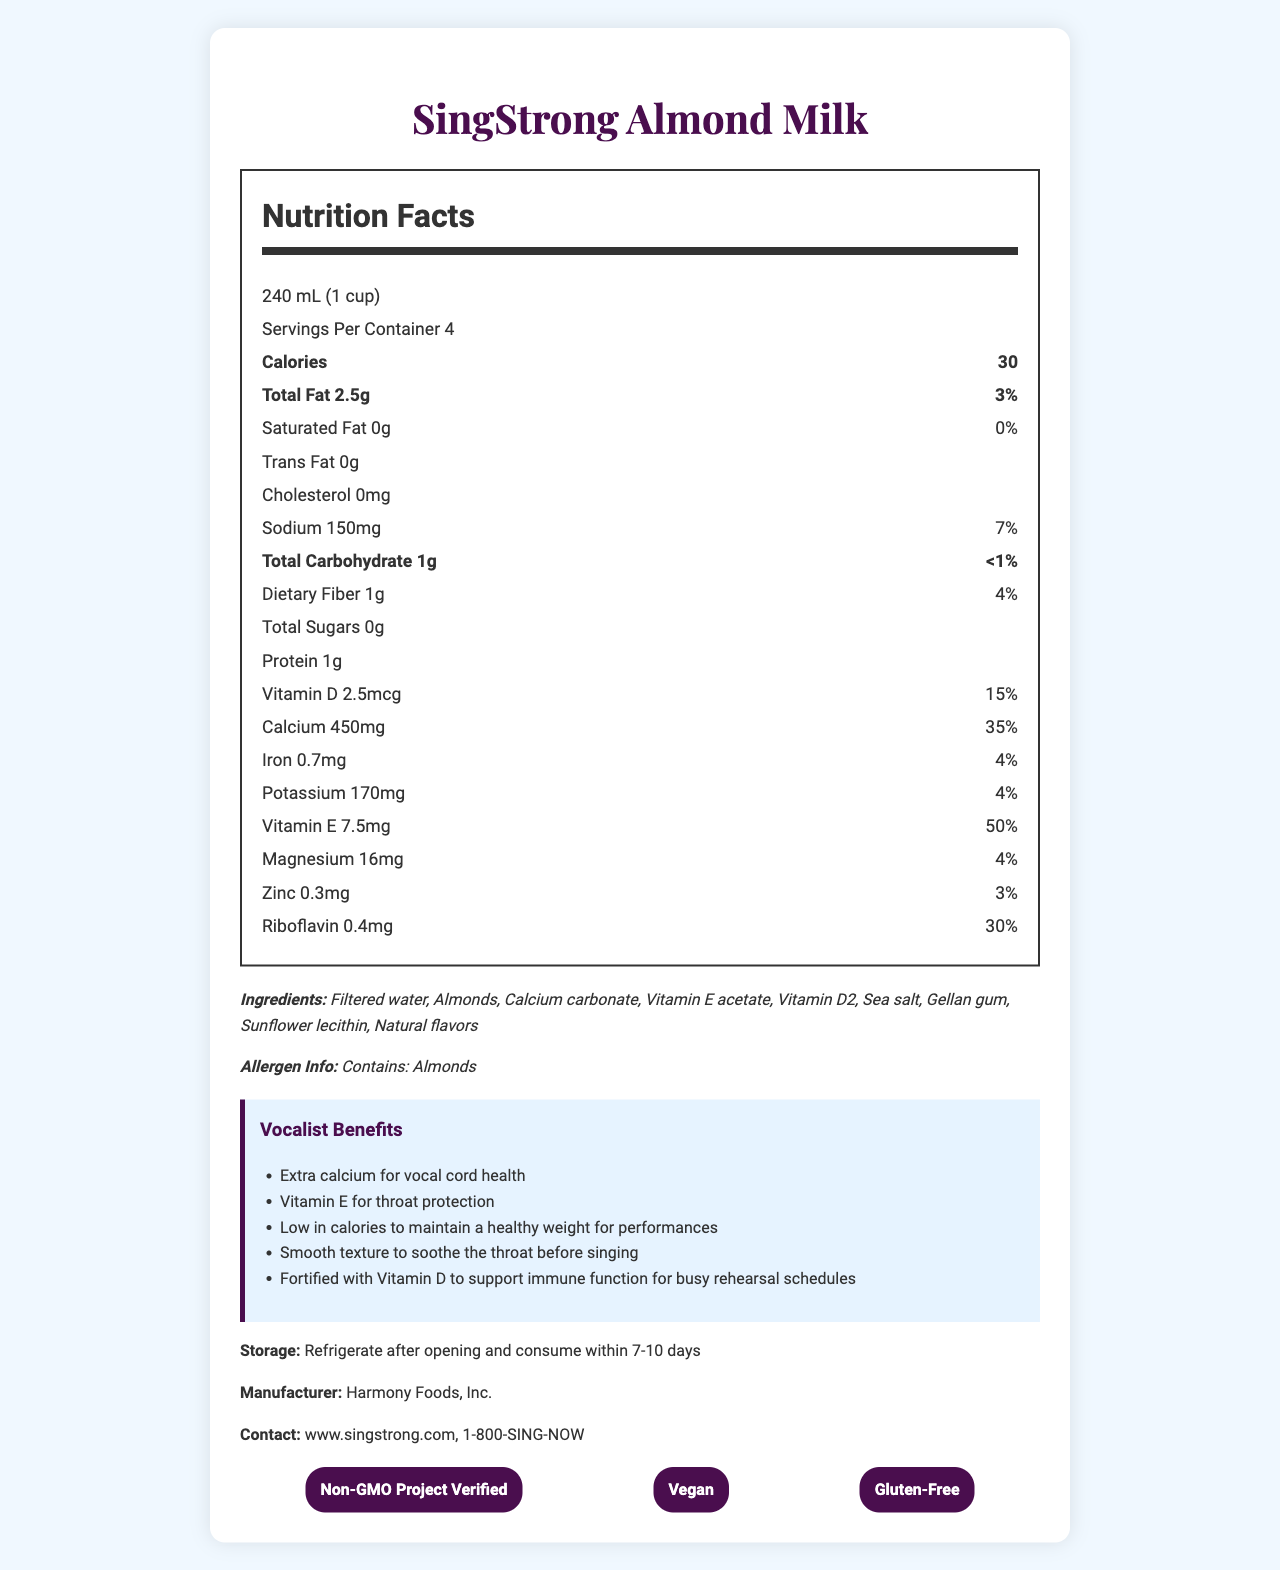what is the serving size of SingStrong Almond Milk? The serving size is clearly specified at the beginning of the nutrition label section.
Answer: 240 mL (1 cup) how many calories are there in one serving? The calories per serving are listed next to the serving size information.
Answer: 30 what is the amount of sodium in one serving? The sodium amount is listed under the nutrition facts with its daily value percentage.
Answer: 150mg how much calcium does SingStrong Almond Milk provide per serving? The calcium amount and its daily value are prominently mentioned in the nutrition facts.
Answer: 450mg how much protein is in a serving? The protein content is listed under the nutrition facts.
Answer: 1g What ingredients are used in SingStrong Almond Milk? The ingredients are listed under the ingredients section of the document.
Answer: Filtered water, Almonds, Calcium carbonate, Vitamin E acetate, Vitamin D2, Sea salt, Gellan gum, Sunflower lecithin, Natural flavors What certifications does SingStrong Almond Milk have? A. Organic B. Non-GMO Project Verified C. Kosher D. Gluten-Free The certifications listed are Non-GMO Project Verified, Vegan, Gluten-Free.
Answer: B, D Which vitamin is present in the highest daily value percentage in SingStrong Almond Milk? A. Vitamin D B. Vitamin E C. Riboflavin D. Iron Vitamin E has a daily value of 50%, whereas Vitamin D has 15%, Riboflavin has 30%, and Iron has 4%.
Answer: B Does SingStrong Almond Milk contain any allergens? It contains almonds, as indicated under the allergen information section.
Answer: Yes Is SingStrong Almond Milk gluten-free? The document mentions that the product is certified as Gluten-Free.
Answer: Yes Summarize the main benefits of SingStrong Almond Milk for vocalists. The benefits specific to vocalists are highlighted in a dedicated section in the document, listing how the product supports vocal health and performance.
Answer: SingStrong Almond Milk provides extra calcium for vocal cord health, vitamin E for throat protection, low calories for a healthy weight, a smooth texture to soothe the throat, and vitamin D to support immune function during busy schedules. what is the expiration policy after opening SingStrong Almond Milk? The storage instructions specify that the product should be refrigerated and consumed within this time frame for best quality.
Answer: Refrigerate after opening and consume within 7-10 days Name the manufacturer of SingStrong Almond Milk. The manufacturer information is listed at the end of the document.
Answer: Harmony Foods, Inc. Is SingStrong Almond Milk suitable for vegans? The product is marked as Vegan in the certifications section.
Answer: Yes What is the primary focus of SingStrong Almond Milk's marketing towards vocalists? The document lists several specific benefits geared towards vocalists, summarizing the focus of its marketing strategy.
Answer: The product focuses on providing nutrients beneficial to vocalists, such as extra calcium for vocal cord health, vitamin E and D for throat protection and immune function, low calories for maintaining a healthy weight, and a smooth texture to soothe the throat. how much weight can a vocalist lose by switching to SingStrong Almond Milk? The document does not provide information on weight loss or caloric deficit, only the calorie content per serving.
Answer: Cannot be determined 